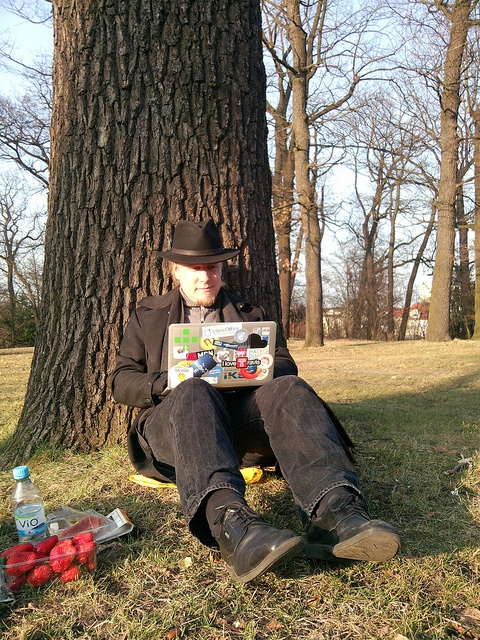Describe the objects in this image and their specific colors. I can see people in lavender, gray, black, and maroon tones, laptop in lavender, ivory, tan, and darkgray tones, and bottle in lavender, darkgray, gray, tan, and ivory tones in this image. 